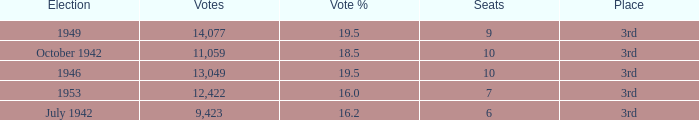Name the total number of seats for votes % more than 19.5 0.0. Help me parse the entirety of this table. {'header': ['Election', 'Votes', 'Vote %', 'Seats', 'Place'], 'rows': [['1949', '14,077', '19.5', '9', '3rd'], ['October 1942', '11,059', '18.5', '10', '3rd'], ['1946', '13,049', '19.5', '10', '3rd'], ['1953', '12,422', '16.0', '7', '3rd'], ['July 1942', '9,423', '16.2', '6', '3rd']]} 